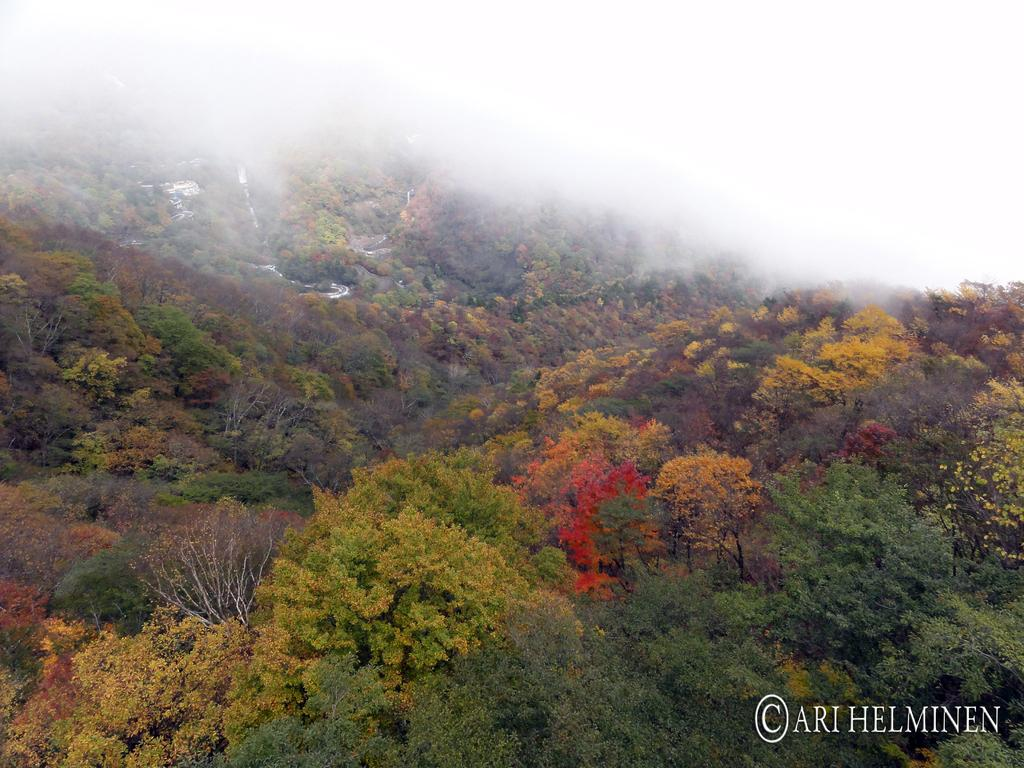What type of vegetation can be seen in the image? There are trees in the image. Is there any text or marking in the image? Yes, there is a watermark in the bottom right corner of the image. How many cherries are hanging from the branches of the trees in the image? There is no mention of cherries in the image, so we cannot determine the number of cherries present. What type of behavior can be observed in the owl in the image? There is no owl present in the image, so we cannot observe any behavior related to an owl. 